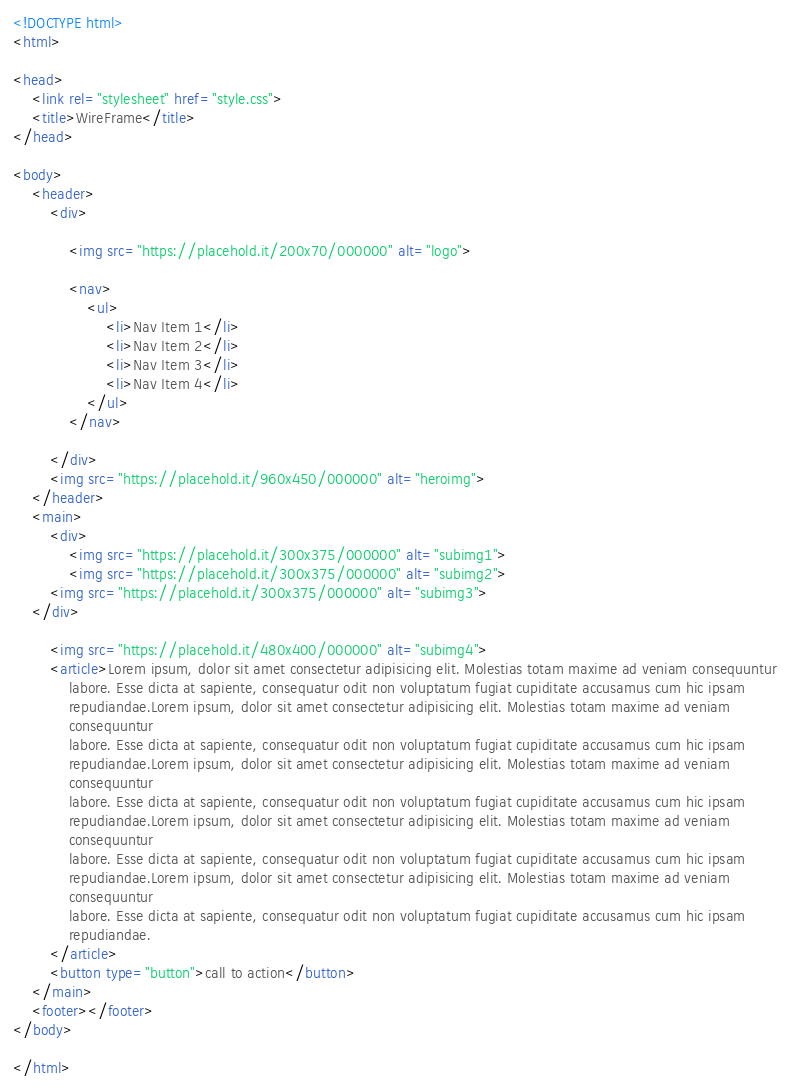Convert code to text. <code><loc_0><loc_0><loc_500><loc_500><_HTML_><!DOCTYPE html>
<html>

<head>
    <link rel="stylesheet" href="style.css">
    <title>WireFrame</title>
</head>

<body>
    <header>
        <div>

            <img src="https://placehold.it/200x70/000000" alt="logo">

            <nav>
                <ul>
                    <li>Nav Item 1</li>
                    <li>Nav Item 2</li>
                    <li>Nav Item 3</li>
                    <li>Nav Item 4</li>
                </ul>
            </nav>

        </div>
        <img src="https://placehold.it/960x450/000000" alt="heroimg">
    </header>
    <main>
        <div>
            <img src="https://placehold.it/300x375/000000" alt="subimg1">
            <img src="https://placehold.it/300x375/000000" alt="subimg2">
        <img src="https://placehold.it/300x375/000000" alt="subimg3">
    </div>

        <img src="https://placehold.it/480x400/000000" alt="subimg4">
        <article>Lorem ipsum, dolor sit amet consectetur adipisicing elit. Molestias totam maxime ad veniam consequuntur
            labore. Esse dicta at sapiente, consequatur odit non voluptatum fugiat cupiditate accusamus cum hic ipsam
            repudiandae.Lorem ipsum, dolor sit amet consectetur adipisicing elit. Molestias totam maxime ad veniam
            consequuntur
            labore. Esse dicta at sapiente, consequatur odit non voluptatum fugiat cupiditate accusamus cum hic ipsam
            repudiandae.Lorem ipsum, dolor sit amet consectetur adipisicing elit. Molestias totam maxime ad veniam
            consequuntur
            labore. Esse dicta at sapiente, consequatur odit non voluptatum fugiat cupiditate accusamus cum hic ipsam
            repudiandae.Lorem ipsum, dolor sit amet consectetur adipisicing elit. Molestias totam maxime ad veniam
            consequuntur
            labore. Esse dicta at sapiente, consequatur odit non voluptatum fugiat cupiditate accusamus cum hic ipsam
            repudiandae.Lorem ipsum, dolor sit amet consectetur adipisicing elit. Molestias totam maxime ad veniam
            consequuntur
            labore. Esse dicta at sapiente, consequatur odit non voluptatum fugiat cupiditate accusamus cum hic ipsam
            repudiandae.
        </article>
        <button type="button">call to action</button>
    </main>
    <footer></footer>
</body>

</html></code> 